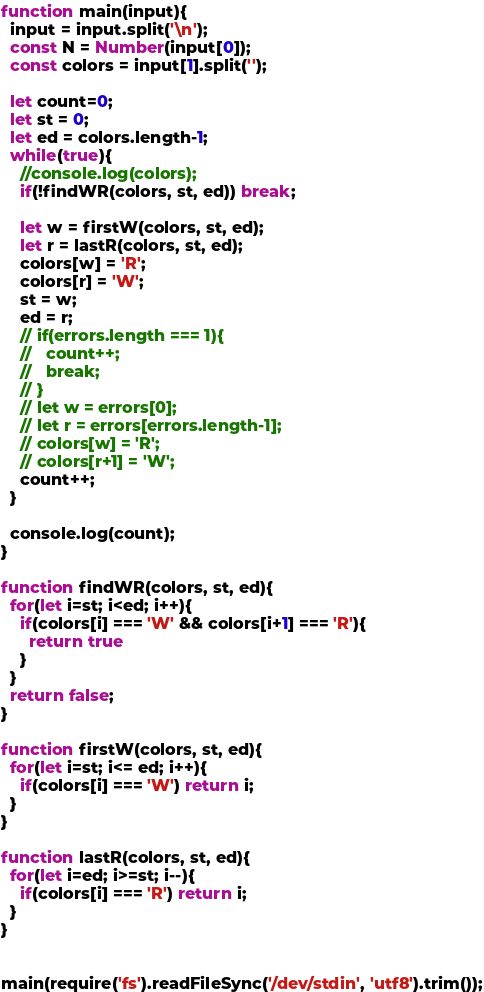Convert code to text. <code><loc_0><loc_0><loc_500><loc_500><_JavaScript_>function main(input){
  input = input.split('\n');
  const N = Number(input[0]);
  const colors = input[1].split('');

  let count=0;
  let st = 0;
  let ed = colors.length-1;
  while(true){
    //console.log(colors);
    if(!findWR(colors, st, ed)) break;

    let w = firstW(colors, st, ed);
    let r = lastR(colors, st, ed);
    colors[w] = 'R';
    colors[r] = 'W';
    st = w;
    ed = r;
    // if(errors.length === 1){
    //   count++;
    //   break;
    // }
    // let w = errors[0];
    // let r = errors[errors.length-1];
    // colors[w] = 'R';
    // colors[r+1] = 'W';
    count++;
  }

  console.log(count);
}

function findWR(colors, st, ed){
  for(let i=st; i<ed; i++){
    if(colors[i] === 'W' && colors[i+1] === 'R'){
      return true
    }
  }
  return false;
}

function firstW(colors, st, ed){
  for(let i=st; i<= ed; i++){
    if(colors[i] === 'W') return i;
  }
}

function lastR(colors, st, ed){
  for(let i=ed; i>=st; i--){
    if(colors[i] === 'R') return i;
  }
}


main(require('fs').readFileSync('/dev/stdin', 'utf8').trim());
</code> 